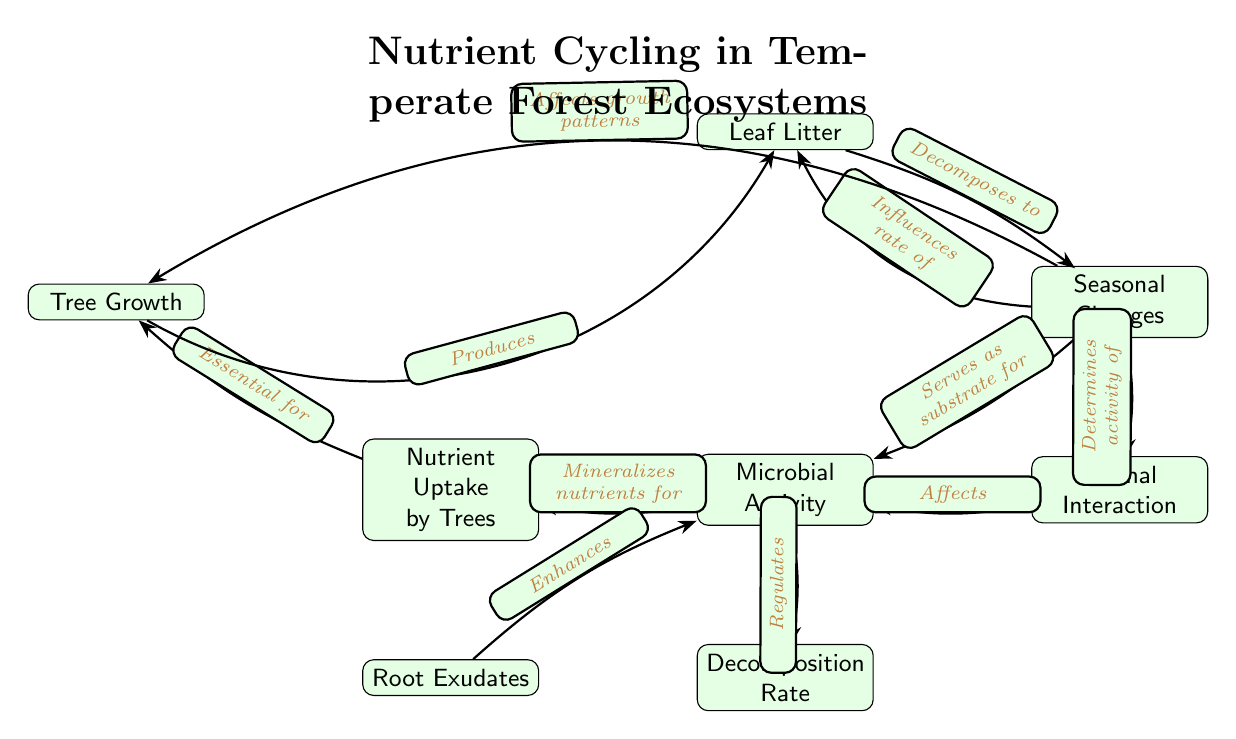What is the starting point of nutrient cycling? In the diagram, the initial node representing the starting point of nutrient cycling is "Leaf Litter".
Answer: Leaf Litter Which node serves as the substrate for microbial activity? According to the diagram, the node directly connected to "Microbial Activity" that serves as a substrate is "Soil Organic Matter".
Answer: Soil Organic Matter How many major processes affect the "Tree Growth"? By analyzing the pathways leading to "Tree Growth", we see that it is affected by the flow from "Nutrient Uptake by Trees" and indirectly through "Seasonal Changes". Therefore, there are two major connections influencing it.
Answer: 2 What enhances microbial activity according to the diagram? The diagram indicates that "Root Exudates" enhances "Microbial Activity", as it has a direct connection to that node.
Answer: Root Exudates What influences the rate of leaf litter production? The node "Seasonal Changes" has a connection labeled "Influences rate of" pointing to "Leaf Litter", indicating that it affects the production of leaf litter.
Answer: Seasonal Changes Which node is regulated by microbial activity? The diagram shows an arrow from "Microbial Activity" to "Decomposition Rate", indicating that microbial activity regulates decomposition.
Answer: Decomposition Rate How does animal interaction affect the nutrient cycle? The edge labeled "Affects" connecting "Animal Interaction" and "Microbial Activity" suggests that animal interaction influences the level of microbial activity in the nutrient cycle.
Answer: Affects Microbial Activity What keeps the nutrient cycling dynamic over seasons? The diagram highlights the influence of "Seasonal Changes" on multiple nodes, particularly on leaf litter production and tree growth, indicating how seasonal variations maintain the nutrient cycling dynamics.
Answer: Seasonal Changes What process is essential for tree growth? The pathway from "Nutrient Uptake by Trees" to "Tree Growth" shows that nutrient uptake is essential for supporting tree growth.
Answer: Nutrient Uptake by Trees 